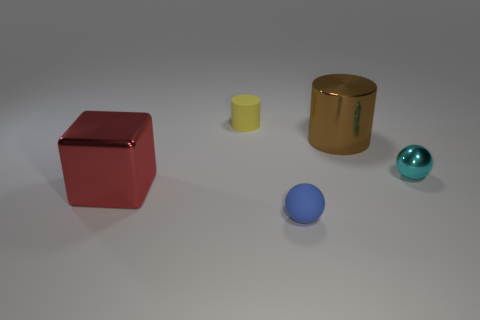Are there any other things that have the same shape as the large red shiny object?
Provide a short and direct response. No. Do the large shiny thing that is to the left of the tiny cylinder and the big shiny object to the right of the rubber cylinder have the same shape?
Keep it short and to the point. No. There is a small blue thing that is the same shape as the cyan thing; what is it made of?
Ensure brevity in your answer.  Rubber. How many cylinders are either small yellow shiny objects or small cyan metallic objects?
Provide a short and direct response. 0. How many blue spheres have the same material as the yellow cylinder?
Your response must be concise. 1. Do the tiny sphere to the left of the brown object and the big thing on the left side of the metal cylinder have the same material?
Provide a succinct answer. No. There is a large brown metallic cylinder behind the rubber thing in front of the cyan object; what number of blocks are behind it?
Provide a short and direct response. 0. Are there any other things that have the same color as the big shiny cylinder?
Give a very brief answer. No. What color is the rubber object that is in front of the large object that is right of the yellow rubber cylinder?
Offer a terse response. Blue. Is there a tiny blue ball?
Provide a short and direct response. Yes. 